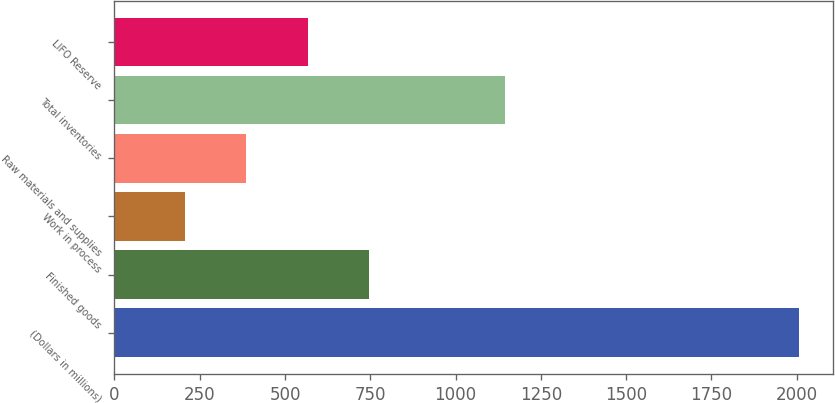<chart> <loc_0><loc_0><loc_500><loc_500><bar_chart><fcel>(Dollars in millions)<fcel>Finished goods<fcel>Work in process<fcel>Raw materials and supplies<fcel>Total inventories<fcel>LIFO Reserve<nl><fcel>2006<fcel>746<fcel>206<fcel>386<fcel>1146<fcel>566<nl></chart> 